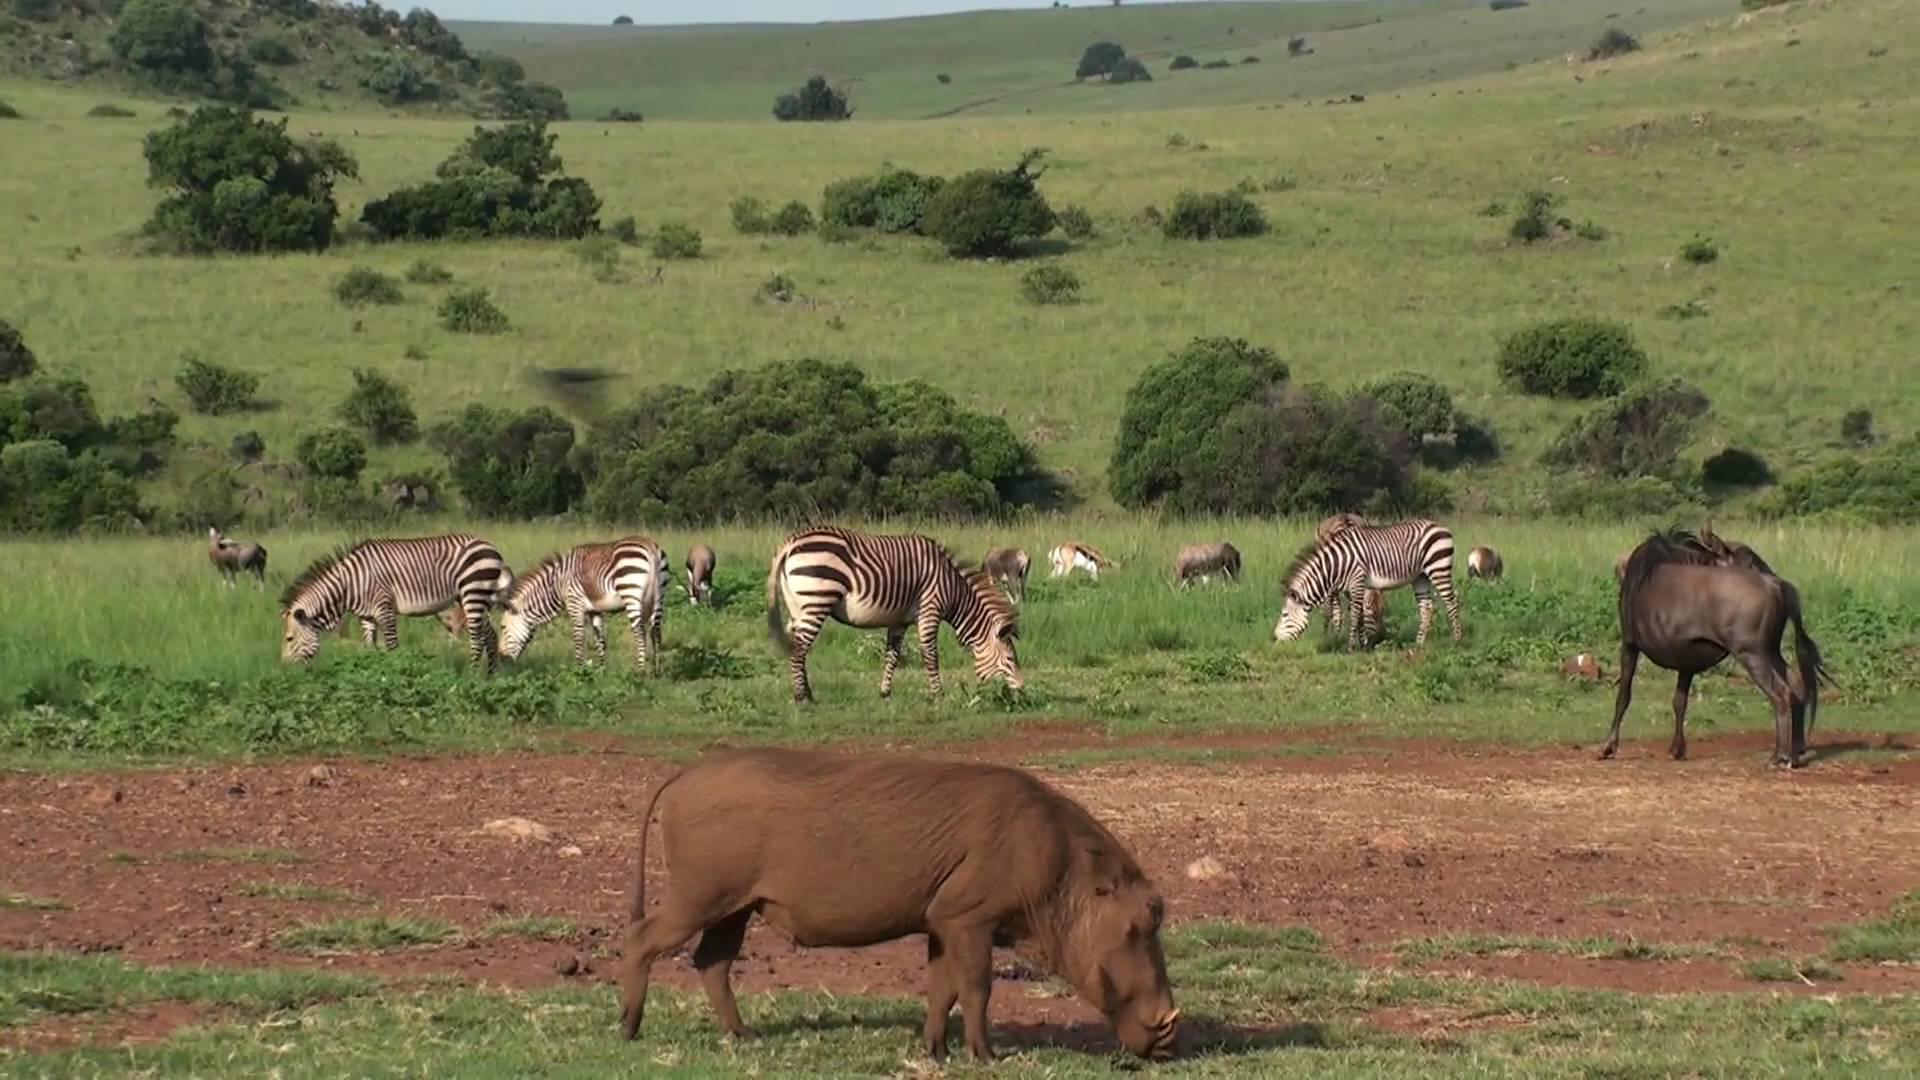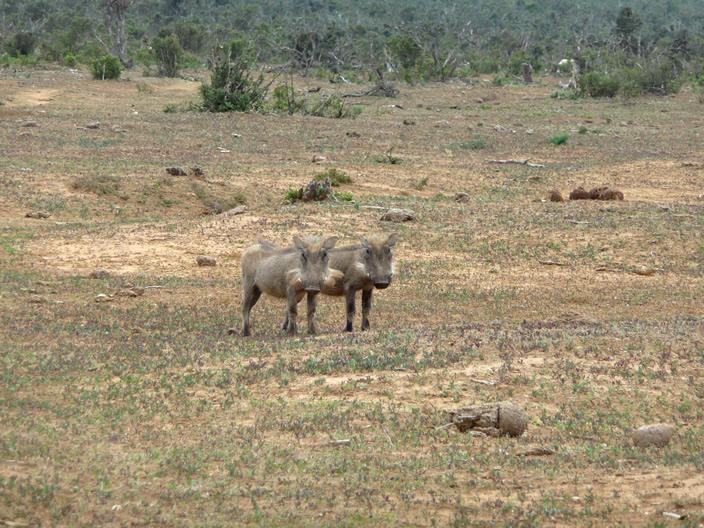The first image is the image on the left, the second image is the image on the right. Evaluate the accuracy of this statement regarding the images: "Multiple zebra are standing behind at least one warthog in an image.". Is it true? Answer yes or no. Yes. 